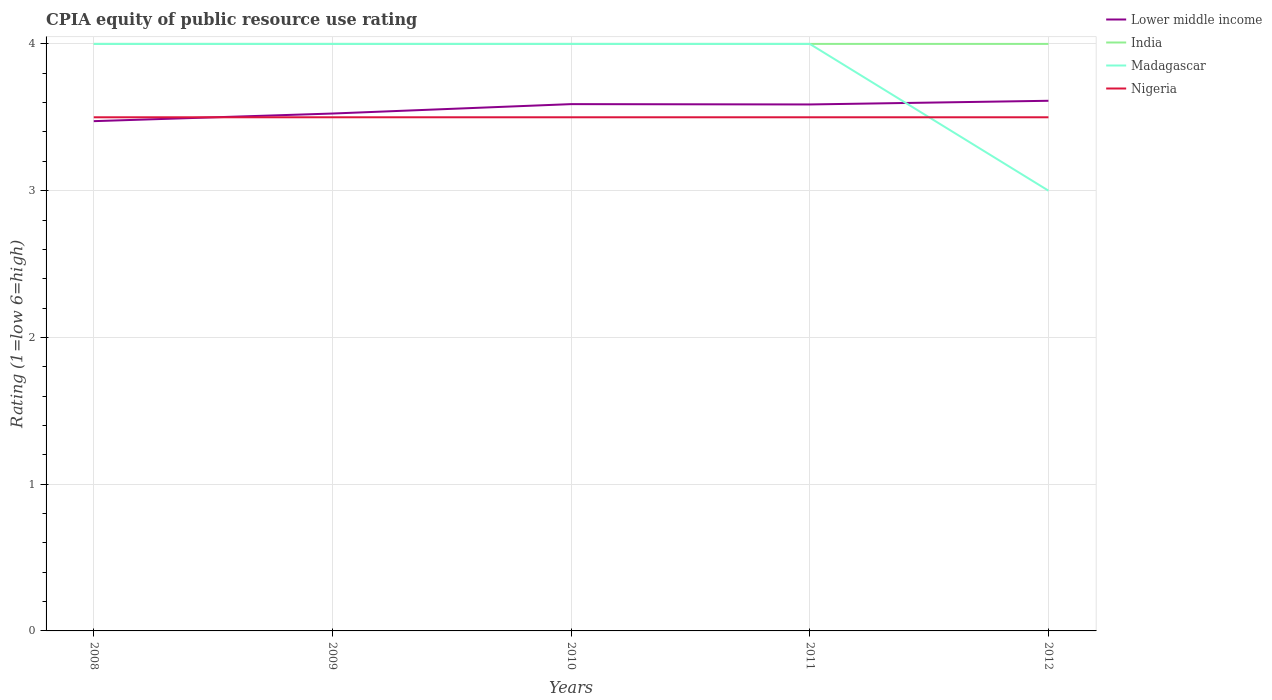How many different coloured lines are there?
Make the answer very short. 4. Is the number of lines equal to the number of legend labels?
Provide a succinct answer. Yes. Across all years, what is the maximum CPIA rating in Nigeria?
Provide a short and direct response. 3.5. In which year was the CPIA rating in Lower middle income maximum?
Your answer should be compact. 2008. What is the total CPIA rating in Nigeria in the graph?
Your answer should be very brief. 0. What is the difference between the highest and the second highest CPIA rating in Nigeria?
Ensure brevity in your answer.  0. What is the difference between the highest and the lowest CPIA rating in Nigeria?
Offer a terse response. 0. Is the CPIA rating in Lower middle income strictly greater than the CPIA rating in Madagascar over the years?
Ensure brevity in your answer.  No. How many years are there in the graph?
Your answer should be compact. 5. Does the graph contain any zero values?
Provide a short and direct response. No. Where does the legend appear in the graph?
Provide a succinct answer. Top right. What is the title of the graph?
Your answer should be very brief. CPIA equity of public resource use rating. What is the label or title of the Y-axis?
Provide a succinct answer. Rating (1=low 6=high). What is the Rating (1=low 6=high) in Lower middle income in 2008?
Offer a very short reply. 3.47. What is the Rating (1=low 6=high) of India in 2008?
Your response must be concise. 4. What is the Rating (1=low 6=high) of Madagascar in 2008?
Make the answer very short. 4. What is the Rating (1=low 6=high) in Lower middle income in 2009?
Offer a terse response. 3.53. What is the Rating (1=low 6=high) in Lower middle income in 2010?
Offer a terse response. 3.59. What is the Rating (1=low 6=high) of India in 2010?
Make the answer very short. 4. What is the Rating (1=low 6=high) in Madagascar in 2010?
Provide a succinct answer. 4. What is the Rating (1=low 6=high) of Lower middle income in 2011?
Your answer should be compact. 3.59. What is the Rating (1=low 6=high) of India in 2011?
Your answer should be very brief. 4. What is the Rating (1=low 6=high) in Nigeria in 2011?
Make the answer very short. 3.5. What is the Rating (1=low 6=high) of Lower middle income in 2012?
Your answer should be very brief. 3.61. What is the Rating (1=low 6=high) of Madagascar in 2012?
Your response must be concise. 3. What is the Rating (1=low 6=high) of Nigeria in 2012?
Ensure brevity in your answer.  3.5. Across all years, what is the maximum Rating (1=low 6=high) in Lower middle income?
Provide a succinct answer. 3.61. Across all years, what is the maximum Rating (1=low 6=high) in India?
Ensure brevity in your answer.  4. Across all years, what is the minimum Rating (1=low 6=high) in Lower middle income?
Ensure brevity in your answer.  3.47. Across all years, what is the minimum Rating (1=low 6=high) in Nigeria?
Offer a very short reply. 3.5. What is the total Rating (1=low 6=high) of Lower middle income in the graph?
Offer a very short reply. 17.79. What is the total Rating (1=low 6=high) in India in the graph?
Your answer should be compact. 20. What is the total Rating (1=low 6=high) of Madagascar in the graph?
Your response must be concise. 19. What is the total Rating (1=low 6=high) of Nigeria in the graph?
Offer a very short reply. 17.5. What is the difference between the Rating (1=low 6=high) in Lower middle income in 2008 and that in 2009?
Offer a terse response. -0.05. What is the difference between the Rating (1=low 6=high) in India in 2008 and that in 2009?
Give a very brief answer. 0. What is the difference between the Rating (1=low 6=high) of Lower middle income in 2008 and that in 2010?
Your answer should be compact. -0.12. What is the difference between the Rating (1=low 6=high) of Madagascar in 2008 and that in 2010?
Offer a very short reply. 0. What is the difference between the Rating (1=low 6=high) of Nigeria in 2008 and that in 2010?
Your answer should be very brief. 0. What is the difference between the Rating (1=low 6=high) of Lower middle income in 2008 and that in 2011?
Ensure brevity in your answer.  -0.11. What is the difference between the Rating (1=low 6=high) in Madagascar in 2008 and that in 2011?
Offer a very short reply. 0. What is the difference between the Rating (1=low 6=high) in Nigeria in 2008 and that in 2011?
Ensure brevity in your answer.  0. What is the difference between the Rating (1=low 6=high) of Lower middle income in 2008 and that in 2012?
Keep it short and to the point. -0.14. What is the difference between the Rating (1=low 6=high) in India in 2008 and that in 2012?
Your answer should be very brief. 0. What is the difference between the Rating (1=low 6=high) of Madagascar in 2008 and that in 2012?
Provide a short and direct response. 1. What is the difference between the Rating (1=low 6=high) in Lower middle income in 2009 and that in 2010?
Offer a very short reply. -0.06. What is the difference between the Rating (1=low 6=high) in India in 2009 and that in 2010?
Give a very brief answer. 0. What is the difference between the Rating (1=low 6=high) of Lower middle income in 2009 and that in 2011?
Your response must be concise. -0.06. What is the difference between the Rating (1=low 6=high) in Madagascar in 2009 and that in 2011?
Ensure brevity in your answer.  0. What is the difference between the Rating (1=low 6=high) of Nigeria in 2009 and that in 2011?
Keep it short and to the point. 0. What is the difference between the Rating (1=low 6=high) of Lower middle income in 2009 and that in 2012?
Provide a short and direct response. -0.09. What is the difference between the Rating (1=low 6=high) of India in 2009 and that in 2012?
Your answer should be very brief. 0. What is the difference between the Rating (1=low 6=high) of Madagascar in 2009 and that in 2012?
Give a very brief answer. 1. What is the difference between the Rating (1=low 6=high) of Lower middle income in 2010 and that in 2011?
Offer a very short reply. 0. What is the difference between the Rating (1=low 6=high) in India in 2010 and that in 2011?
Make the answer very short. 0. What is the difference between the Rating (1=low 6=high) of Lower middle income in 2010 and that in 2012?
Provide a succinct answer. -0.02. What is the difference between the Rating (1=low 6=high) in Madagascar in 2010 and that in 2012?
Your answer should be very brief. 1. What is the difference between the Rating (1=low 6=high) in Nigeria in 2010 and that in 2012?
Your answer should be compact. 0. What is the difference between the Rating (1=low 6=high) in Lower middle income in 2011 and that in 2012?
Make the answer very short. -0.03. What is the difference between the Rating (1=low 6=high) in Lower middle income in 2008 and the Rating (1=low 6=high) in India in 2009?
Offer a very short reply. -0.53. What is the difference between the Rating (1=low 6=high) in Lower middle income in 2008 and the Rating (1=low 6=high) in Madagascar in 2009?
Provide a succinct answer. -0.53. What is the difference between the Rating (1=low 6=high) in Lower middle income in 2008 and the Rating (1=low 6=high) in Nigeria in 2009?
Your answer should be very brief. -0.03. What is the difference between the Rating (1=low 6=high) of Madagascar in 2008 and the Rating (1=low 6=high) of Nigeria in 2009?
Offer a terse response. 0.5. What is the difference between the Rating (1=low 6=high) in Lower middle income in 2008 and the Rating (1=low 6=high) in India in 2010?
Offer a very short reply. -0.53. What is the difference between the Rating (1=low 6=high) in Lower middle income in 2008 and the Rating (1=low 6=high) in Madagascar in 2010?
Your answer should be very brief. -0.53. What is the difference between the Rating (1=low 6=high) in Lower middle income in 2008 and the Rating (1=low 6=high) in Nigeria in 2010?
Your answer should be very brief. -0.03. What is the difference between the Rating (1=low 6=high) in India in 2008 and the Rating (1=low 6=high) in Nigeria in 2010?
Your answer should be compact. 0.5. What is the difference between the Rating (1=low 6=high) in Madagascar in 2008 and the Rating (1=low 6=high) in Nigeria in 2010?
Your answer should be compact. 0.5. What is the difference between the Rating (1=low 6=high) of Lower middle income in 2008 and the Rating (1=low 6=high) of India in 2011?
Keep it short and to the point. -0.53. What is the difference between the Rating (1=low 6=high) in Lower middle income in 2008 and the Rating (1=low 6=high) in Madagascar in 2011?
Offer a terse response. -0.53. What is the difference between the Rating (1=low 6=high) in Lower middle income in 2008 and the Rating (1=low 6=high) in Nigeria in 2011?
Ensure brevity in your answer.  -0.03. What is the difference between the Rating (1=low 6=high) of India in 2008 and the Rating (1=low 6=high) of Nigeria in 2011?
Ensure brevity in your answer.  0.5. What is the difference between the Rating (1=low 6=high) of Lower middle income in 2008 and the Rating (1=low 6=high) of India in 2012?
Provide a short and direct response. -0.53. What is the difference between the Rating (1=low 6=high) of Lower middle income in 2008 and the Rating (1=low 6=high) of Madagascar in 2012?
Provide a succinct answer. 0.47. What is the difference between the Rating (1=low 6=high) of Lower middle income in 2008 and the Rating (1=low 6=high) of Nigeria in 2012?
Give a very brief answer. -0.03. What is the difference between the Rating (1=low 6=high) in India in 2008 and the Rating (1=low 6=high) in Madagascar in 2012?
Give a very brief answer. 1. What is the difference between the Rating (1=low 6=high) in India in 2008 and the Rating (1=low 6=high) in Nigeria in 2012?
Provide a short and direct response. 0.5. What is the difference between the Rating (1=low 6=high) of Madagascar in 2008 and the Rating (1=low 6=high) of Nigeria in 2012?
Provide a succinct answer. 0.5. What is the difference between the Rating (1=low 6=high) in Lower middle income in 2009 and the Rating (1=low 6=high) in India in 2010?
Keep it short and to the point. -0.47. What is the difference between the Rating (1=low 6=high) in Lower middle income in 2009 and the Rating (1=low 6=high) in Madagascar in 2010?
Your response must be concise. -0.47. What is the difference between the Rating (1=low 6=high) in Lower middle income in 2009 and the Rating (1=low 6=high) in Nigeria in 2010?
Offer a very short reply. 0.03. What is the difference between the Rating (1=low 6=high) of India in 2009 and the Rating (1=low 6=high) of Madagascar in 2010?
Ensure brevity in your answer.  0. What is the difference between the Rating (1=low 6=high) of Madagascar in 2009 and the Rating (1=low 6=high) of Nigeria in 2010?
Ensure brevity in your answer.  0.5. What is the difference between the Rating (1=low 6=high) of Lower middle income in 2009 and the Rating (1=low 6=high) of India in 2011?
Offer a terse response. -0.47. What is the difference between the Rating (1=low 6=high) in Lower middle income in 2009 and the Rating (1=low 6=high) in Madagascar in 2011?
Your response must be concise. -0.47. What is the difference between the Rating (1=low 6=high) of Lower middle income in 2009 and the Rating (1=low 6=high) of Nigeria in 2011?
Make the answer very short. 0.03. What is the difference between the Rating (1=low 6=high) of Lower middle income in 2009 and the Rating (1=low 6=high) of India in 2012?
Provide a short and direct response. -0.47. What is the difference between the Rating (1=low 6=high) of Lower middle income in 2009 and the Rating (1=low 6=high) of Madagascar in 2012?
Your answer should be compact. 0.53. What is the difference between the Rating (1=low 6=high) of Lower middle income in 2009 and the Rating (1=low 6=high) of Nigeria in 2012?
Make the answer very short. 0.03. What is the difference between the Rating (1=low 6=high) of India in 2009 and the Rating (1=low 6=high) of Madagascar in 2012?
Provide a short and direct response. 1. What is the difference between the Rating (1=low 6=high) of India in 2009 and the Rating (1=low 6=high) of Nigeria in 2012?
Ensure brevity in your answer.  0.5. What is the difference between the Rating (1=low 6=high) of Madagascar in 2009 and the Rating (1=low 6=high) of Nigeria in 2012?
Offer a terse response. 0.5. What is the difference between the Rating (1=low 6=high) of Lower middle income in 2010 and the Rating (1=low 6=high) of India in 2011?
Your response must be concise. -0.41. What is the difference between the Rating (1=low 6=high) in Lower middle income in 2010 and the Rating (1=low 6=high) in Madagascar in 2011?
Your answer should be very brief. -0.41. What is the difference between the Rating (1=low 6=high) of Lower middle income in 2010 and the Rating (1=low 6=high) of Nigeria in 2011?
Keep it short and to the point. 0.09. What is the difference between the Rating (1=low 6=high) of India in 2010 and the Rating (1=low 6=high) of Madagascar in 2011?
Provide a short and direct response. 0. What is the difference between the Rating (1=low 6=high) in Lower middle income in 2010 and the Rating (1=low 6=high) in India in 2012?
Offer a terse response. -0.41. What is the difference between the Rating (1=low 6=high) in Lower middle income in 2010 and the Rating (1=low 6=high) in Madagascar in 2012?
Offer a very short reply. 0.59. What is the difference between the Rating (1=low 6=high) in Lower middle income in 2010 and the Rating (1=low 6=high) in Nigeria in 2012?
Make the answer very short. 0.09. What is the difference between the Rating (1=low 6=high) of Lower middle income in 2011 and the Rating (1=low 6=high) of India in 2012?
Your answer should be very brief. -0.41. What is the difference between the Rating (1=low 6=high) of Lower middle income in 2011 and the Rating (1=low 6=high) of Madagascar in 2012?
Offer a very short reply. 0.59. What is the difference between the Rating (1=low 6=high) in Lower middle income in 2011 and the Rating (1=low 6=high) in Nigeria in 2012?
Ensure brevity in your answer.  0.09. What is the difference between the Rating (1=low 6=high) of India in 2011 and the Rating (1=low 6=high) of Madagascar in 2012?
Provide a succinct answer. 1. What is the difference between the Rating (1=low 6=high) in Madagascar in 2011 and the Rating (1=low 6=high) in Nigeria in 2012?
Your answer should be very brief. 0.5. What is the average Rating (1=low 6=high) of Lower middle income per year?
Your answer should be very brief. 3.56. What is the average Rating (1=low 6=high) of Madagascar per year?
Offer a very short reply. 3.8. What is the average Rating (1=low 6=high) of Nigeria per year?
Your answer should be compact. 3.5. In the year 2008, what is the difference between the Rating (1=low 6=high) in Lower middle income and Rating (1=low 6=high) in India?
Your answer should be very brief. -0.53. In the year 2008, what is the difference between the Rating (1=low 6=high) in Lower middle income and Rating (1=low 6=high) in Madagascar?
Offer a terse response. -0.53. In the year 2008, what is the difference between the Rating (1=low 6=high) in Lower middle income and Rating (1=low 6=high) in Nigeria?
Make the answer very short. -0.03. In the year 2008, what is the difference between the Rating (1=low 6=high) of India and Rating (1=low 6=high) of Nigeria?
Provide a short and direct response. 0.5. In the year 2008, what is the difference between the Rating (1=low 6=high) in Madagascar and Rating (1=low 6=high) in Nigeria?
Offer a terse response. 0.5. In the year 2009, what is the difference between the Rating (1=low 6=high) of Lower middle income and Rating (1=low 6=high) of India?
Make the answer very short. -0.47. In the year 2009, what is the difference between the Rating (1=low 6=high) of Lower middle income and Rating (1=low 6=high) of Madagascar?
Your answer should be compact. -0.47. In the year 2009, what is the difference between the Rating (1=low 6=high) in Lower middle income and Rating (1=low 6=high) in Nigeria?
Your answer should be very brief. 0.03. In the year 2009, what is the difference between the Rating (1=low 6=high) of India and Rating (1=low 6=high) of Nigeria?
Give a very brief answer. 0.5. In the year 2010, what is the difference between the Rating (1=low 6=high) in Lower middle income and Rating (1=low 6=high) in India?
Your response must be concise. -0.41. In the year 2010, what is the difference between the Rating (1=low 6=high) in Lower middle income and Rating (1=low 6=high) in Madagascar?
Provide a short and direct response. -0.41. In the year 2010, what is the difference between the Rating (1=low 6=high) of Lower middle income and Rating (1=low 6=high) of Nigeria?
Your answer should be compact. 0.09. In the year 2010, what is the difference between the Rating (1=low 6=high) of India and Rating (1=low 6=high) of Nigeria?
Keep it short and to the point. 0.5. In the year 2011, what is the difference between the Rating (1=low 6=high) in Lower middle income and Rating (1=low 6=high) in India?
Ensure brevity in your answer.  -0.41. In the year 2011, what is the difference between the Rating (1=low 6=high) of Lower middle income and Rating (1=low 6=high) of Madagascar?
Provide a succinct answer. -0.41. In the year 2011, what is the difference between the Rating (1=low 6=high) in Lower middle income and Rating (1=low 6=high) in Nigeria?
Keep it short and to the point. 0.09. In the year 2011, what is the difference between the Rating (1=low 6=high) in India and Rating (1=low 6=high) in Nigeria?
Make the answer very short. 0.5. In the year 2011, what is the difference between the Rating (1=low 6=high) in Madagascar and Rating (1=low 6=high) in Nigeria?
Offer a very short reply. 0.5. In the year 2012, what is the difference between the Rating (1=low 6=high) of Lower middle income and Rating (1=low 6=high) of India?
Keep it short and to the point. -0.39. In the year 2012, what is the difference between the Rating (1=low 6=high) in Lower middle income and Rating (1=low 6=high) in Madagascar?
Offer a very short reply. 0.61. In the year 2012, what is the difference between the Rating (1=low 6=high) of Lower middle income and Rating (1=low 6=high) of Nigeria?
Your response must be concise. 0.11. In the year 2012, what is the difference between the Rating (1=low 6=high) of India and Rating (1=low 6=high) of Madagascar?
Your response must be concise. 1. In the year 2012, what is the difference between the Rating (1=low 6=high) in Madagascar and Rating (1=low 6=high) in Nigeria?
Your response must be concise. -0.5. What is the ratio of the Rating (1=low 6=high) of Madagascar in 2008 to that in 2009?
Keep it short and to the point. 1. What is the ratio of the Rating (1=low 6=high) in Nigeria in 2008 to that in 2009?
Offer a very short reply. 1. What is the ratio of the Rating (1=low 6=high) in Madagascar in 2008 to that in 2010?
Ensure brevity in your answer.  1. What is the ratio of the Rating (1=low 6=high) in Lower middle income in 2008 to that in 2011?
Keep it short and to the point. 0.97. What is the ratio of the Rating (1=low 6=high) of Lower middle income in 2008 to that in 2012?
Your answer should be very brief. 0.96. What is the ratio of the Rating (1=low 6=high) in India in 2008 to that in 2012?
Provide a succinct answer. 1. What is the ratio of the Rating (1=low 6=high) of Nigeria in 2008 to that in 2012?
Your answer should be very brief. 1. What is the ratio of the Rating (1=low 6=high) of Lower middle income in 2009 to that in 2010?
Offer a very short reply. 0.98. What is the ratio of the Rating (1=low 6=high) in Lower middle income in 2009 to that in 2011?
Ensure brevity in your answer.  0.98. What is the ratio of the Rating (1=low 6=high) in India in 2009 to that in 2011?
Your answer should be very brief. 1. What is the ratio of the Rating (1=low 6=high) in Madagascar in 2009 to that in 2011?
Ensure brevity in your answer.  1. What is the ratio of the Rating (1=low 6=high) of Madagascar in 2009 to that in 2012?
Provide a short and direct response. 1.33. What is the ratio of the Rating (1=low 6=high) of Nigeria in 2009 to that in 2012?
Give a very brief answer. 1. What is the ratio of the Rating (1=low 6=high) in Lower middle income in 2010 to that in 2011?
Ensure brevity in your answer.  1. What is the ratio of the Rating (1=low 6=high) of India in 2010 to that in 2011?
Keep it short and to the point. 1. What is the ratio of the Rating (1=low 6=high) in Nigeria in 2010 to that in 2012?
Provide a short and direct response. 1. What is the ratio of the Rating (1=low 6=high) of Lower middle income in 2011 to that in 2012?
Give a very brief answer. 0.99. What is the difference between the highest and the second highest Rating (1=low 6=high) of Lower middle income?
Ensure brevity in your answer.  0.02. What is the difference between the highest and the second highest Rating (1=low 6=high) of India?
Your answer should be very brief. 0. What is the difference between the highest and the second highest Rating (1=low 6=high) of Madagascar?
Give a very brief answer. 0. What is the difference between the highest and the second highest Rating (1=low 6=high) in Nigeria?
Make the answer very short. 0. What is the difference between the highest and the lowest Rating (1=low 6=high) of Lower middle income?
Give a very brief answer. 0.14. What is the difference between the highest and the lowest Rating (1=low 6=high) in India?
Give a very brief answer. 0. What is the difference between the highest and the lowest Rating (1=low 6=high) in Madagascar?
Keep it short and to the point. 1. What is the difference between the highest and the lowest Rating (1=low 6=high) in Nigeria?
Provide a succinct answer. 0. 